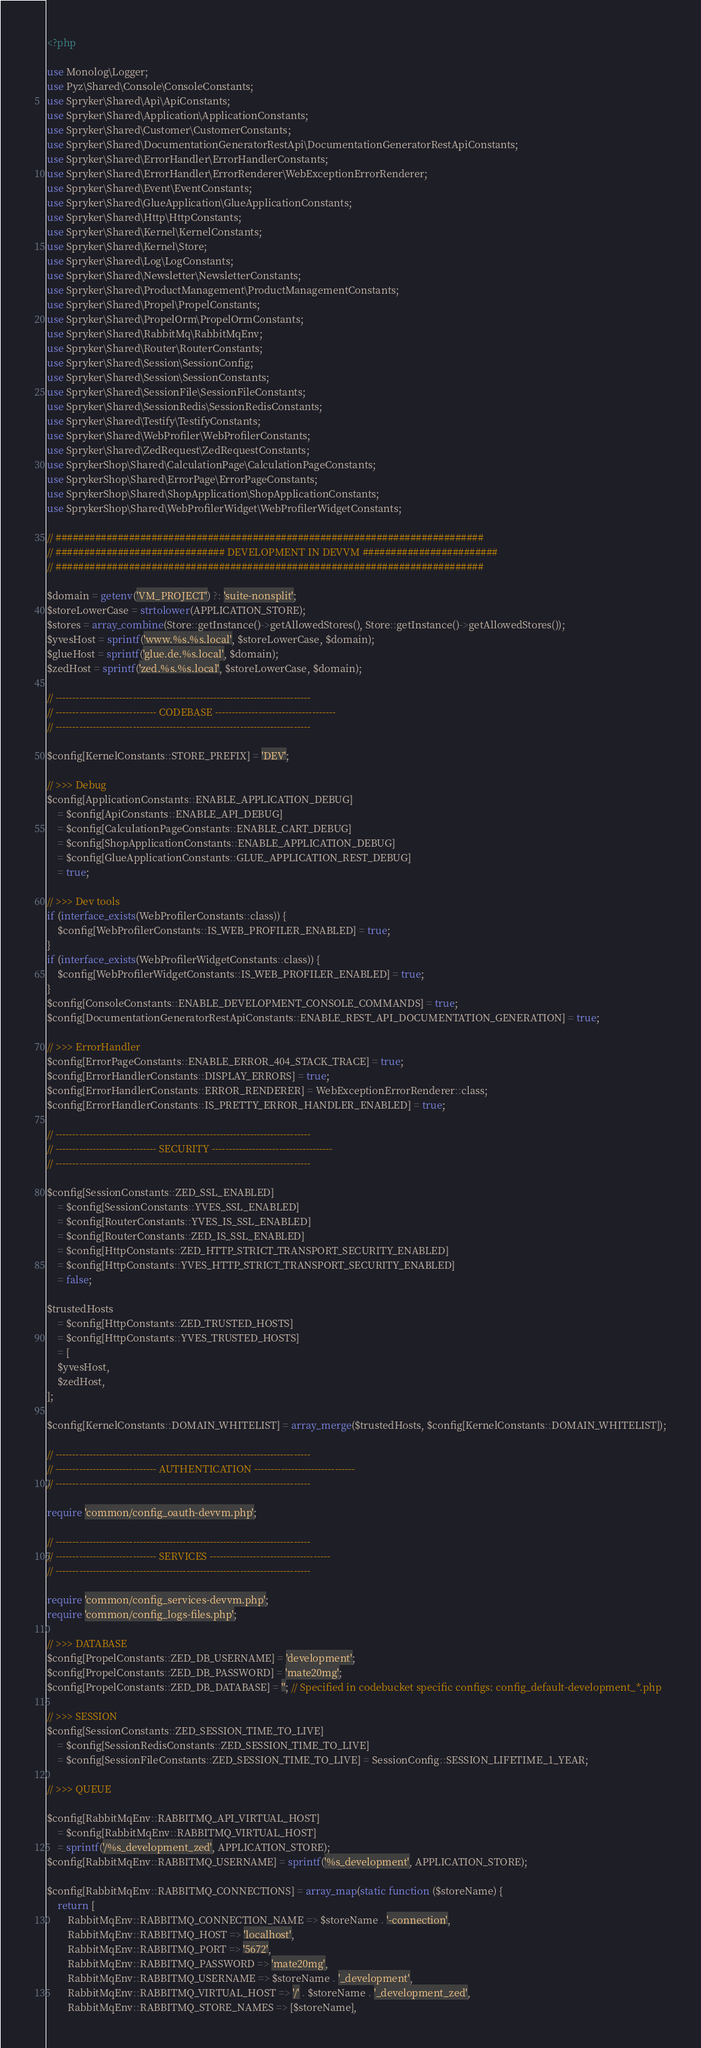Convert code to text. <code><loc_0><loc_0><loc_500><loc_500><_PHP_><?php

use Monolog\Logger;
use Pyz\Shared\Console\ConsoleConstants;
use Spryker\Shared\Api\ApiConstants;
use Spryker\Shared\Application\ApplicationConstants;
use Spryker\Shared\Customer\CustomerConstants;
use Spryker\Shared\DocumentationGeneratorRestApi\DocumentationGeneratorRestApiConstants;
use Spryker\Shared\ErrorHandler\ErrorHandlerConstants;
use Spryker\Shared\ErrorHandler\ErrorRenderer\WebExceptionErrorRenderer;
use Spryker\Shared\Event\EventConstants;
use Spryker\Shared\GlueApplication\GlueApplicationConstants;
use Spryker\Shared\Http\HttpConstants;
use Spryker\Shared\Kernel\KernelConstants;
use Spryker\Shared\Kernel\Store;
use Spryker\Shared\Log\LogConstants;
use Spryker\Shared\Newsletter\NewsletterConstants;
use Spryker\Shared\ProductManagement\ProductManagementConstants;
use Spryker\Shared\Propel\PropelConstants;
use Spryker\Shared\PropelOrm\PropelOrmConstants;
use Spryker\Shared\RabbitMq\RabbitMqEnv;
use Spryker\Shared\Router\RouterConstants;
use Spryker\Shared\Session\SessionConfig;
use Spryker\Shared\Session\SessionConstants;
use Spryker\Shared\SessionFile\SessionFileConstants;
use Spryker\Shared\SessionRedis\SessionRedisConstants;
use Spryker\Shared\Testify\TestifyConstants;
use Spryker\Shared\WebProfiler\WebProfilerConstants;
use Spryker\Shared\ZedRequest\ZedRequestConstants;
use SprykerShop\Shared\CalculationPage\CalculationPageConstants;
use SprykerShop\Shared\ErrorPage\ErrorPageConstants;
use SprykerShop\Shared\ShopApplication\ShopApplicationConstants;
use SprykerShop\Shared\WebProfilerWidget\WebProfilerWidgetConstants;

// ############################################################################
// ############################## DEVELOPMENT IN DEVVM ########################
// ############################################################################

$domain = getenv('VM_PROJECT') ?: 'suite-nonsplit';
$storeLowerCase = strtolower(APPLICATION_STORE);
$stores = array_combine(Store::getInstance()->getAllowedStores(), Store::getInstance()->getAllowedStores());
$yvesHost = sprintf('www.%s.%s.local', $storeLowerCase, $domain);
$glueHost = sprintf('glue.de.%s.local', $domain);
$zedHost = sprintf('zed.%s.%s.local', $storeLowerCase, $domain);

// ----------------------------------------------------------------------------
// ------------------------------ CODEBASE ------------------------------------
// ----------------------------------------------------------------------------

$config[KernelConstants::STORE_PREFIX] = 'DEV';

// >>> Debug
$config[ApplicationConstants::ENABLE_APPLICATION_DEBUG]
    = $config[ApiConstants::ENABLE_API_DEBUG]
    = $config[CalculationPageConstants::ENABLE_CART_DEBUG]
    = $config[ShopApplicationConstants::ENABLE_APPLICATION_DEBUG]
    = $config[GlueApplicationConstants::GLUE_APPLICATION_REST_DEBUG]
    = true;

// >>> Dev tools
if (interface_exists(WebProfilerConstants::class)) {
    $config[WebProfilerConstants::IS_WEB_PROFILER_ENABLED] = true;
}
if (interface_exists(WebProfilerWidgetConstants::class)) {
    $config[WebProfilerWidgetConstants::IS_WEB_PROFILER_ENABLED] = true;
}
$config[ConsoleConstants::ENABLE_DEVELOPMENT_CONSOLE_COMMANDS] = true;
$config[DocumentationGeneratorRestApiConstants::ENABLE_REST_API_DOCUMENTATION_GENERATION] = true;

// >>> ErrorHandler
$config[ErrorPageConstants::ENABLE_ERROR_404_STACK_TRACE] = true;
$config[ErrorHandlerConstants::DISPLAY_ERRORS] = true;
$config[ErrorHandlerConstants::ERROR_RENDERER] = WebExceptionErrorRenderer::class;
$config[ErrorHandlerConstants::IS_PRETTY_ERROR_HANDLER_ENABLED] = true;

// ----------------------------------------------------------------------------
// ------------------------------ SECURITY ------------------------------------
// ----------------------------------------------------------------------------

$config[SessionConstants::ZED_SSL_ENABLED]
    = $config[SessionConstants::YVES_SSL_ENABLED]
    = $config[RouterConstants::YVES_IS_SSL_ENABLED]
    = $config[RouterConstants::ZED_IS_SSL_ENABLED]
    = $config[HttpConstants::ZED_HTTP_STRICT_TRANSPORT_SECURITY_ENABLED]
    = $config[HttpConstants::YVES_HTTP_STRICT_TRANSPORT_SECURITY_ENABLED]
    = false;

$trustedHosts
    = $config[HttpConstants::ZED_TRUSTED_HOSTS]
    = $config[HttpConstants::YVES_TRUSTED_HOSTS]
    = [
    $yvesHost,
    $zedHost,
];

$config[KernelConstants::DOMAIN_WHITELIST] = array_merge($trustedHosts, $config[KernelConstants::DOMAIN_WHITELIST]);

// ----------------------------------------------------------------------------
// ------------------------------ AUTHENTICATION ------------------------------
// ----------------------------------------------------------------------------

require 'common/config_oauth-devvm.php';

// ----------------------------------------------------------------------------
// ------------------------------ SERVICES ------------------------------------
// ----------------------------------------------------------------------------

require 'common/config_services-devvm.php';
require 'common/config_logs-files.php';

// >>> DATABASE
$config[PropelConstants::ZED_DB_USERNAME] = 'development';
$config[PropelConstants::ZED_DB_PASSWORD] = 'mate20mg';
$config[PropelConstants::ZED_DB_DATABASE] = ''; // Specified in codebucket specific configs: config_default-development_*.php

// >>> SESSION
$config[SessionConstants::ZED_SESSION_TIME_TO_LIVE]
    = $config[SessionRedisConstants::ZED_SESSION_TIME_TO_LIVE]
    = $config[SessionFileConstants::ZED_SESSION_TIME_TO_LIVE] = SessionConfig::SESSION_LIFETIME_1_YEAR;

// >>> QUEUE

$config[RabbitMqEnv::RABBITMQ_API_VIRTUAL_HOST]
    = $config[RabbitMqEnv::RABBITMQ_VIRTUAL_HOST]
    = sprintf('/%s_development_zed', APPLICATION_STORE);
$config[RabbitMqEnv::RABBITMQ_USERNAME] = sprintf('%s_development', APPLICATION_STORE);

$config[RabbitMqEnv::RABBITMQ_CONNECTIONS] = array_map(static function ($storeName) {
    return [
        RabbitMqEnv::RABBITMQ_CONNECTION_NAME => $storeName . '-connection',
        RabbitMqEnv::RABBITMQ_HOST => 'localhost',
        RabbitMqEnv::RABBITMQ_PORT => '5672',
        RabbitMqEnv::RABBITMQ_PASSWORD => 'mate20mg',
        RabbitMqEnv::RABBITMQ_USERNAME => $storeName . '_development',
        RabbitMqEnv::RABBITMQ_VIRTUAL_HOST => '/' . $storeName . '_development_zed',
        RabbitMqEnv::RABBITMQ_STORE_NAMES => [$storeName],</code> 